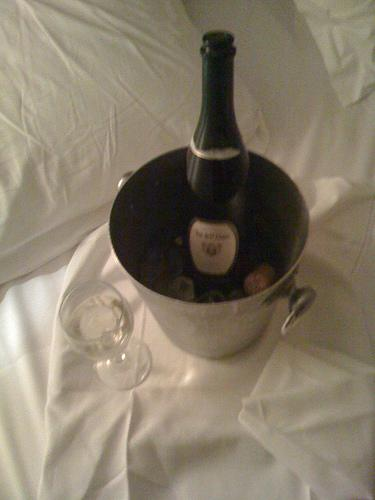Question: what is next to the can?
Choices:
A. Dirty tissues.
B. Nothing.
C. A glass.
D. A raccoon.
Answer with the letter. Answer: C Question: what is in the can?
Choices:
A. Trash.
B. Fruit.
C. Money.
D. A bottle.
Answer with the letter. Answer: D Question: what kind of glass is it?
Choices:
A. Water glass.
B. Stained glass.
C. Wine glass.
D. Broken glass.
Answer with the letter. Answer: C Question: who is in the photo?
Choices:
A. A family.
B. No one.
C. An umpire.
D. A large woman.
Answer with the letter. Answer: B 